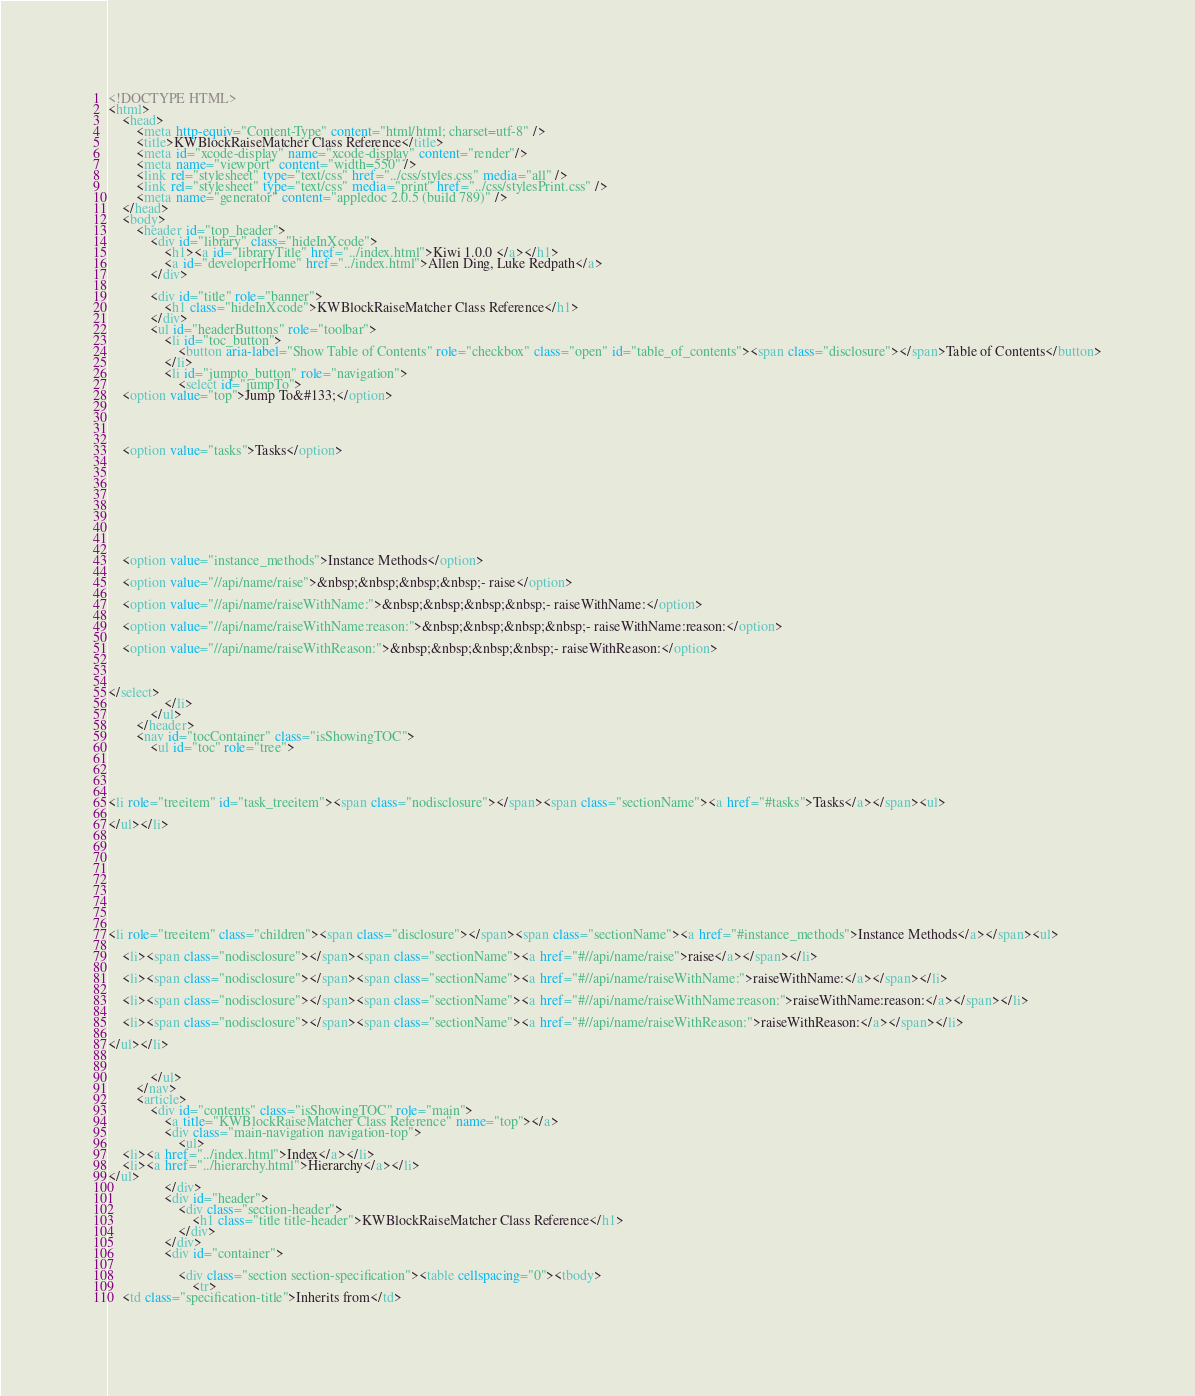<code> <loc_0><loc_0><loc_500><loc_500><_HTML_><!DOCTYPE HTML>
<html>
	<head>
		<meta http-equiv="Content-Type" content="html/html; charset=utf-8" />
		<title>KWBlockRaiseMatcher Class Reference</title>
		<meta id="xcode-display" name="xcode-display" content="render"/>
		<meta name="viewport" content="width=550" />
		<link rel="stylesheet" type="text/css" href="../css/styles.css" media="all" />
		<link rel="stylesheet" type="text/css" media="print" href="../css/stylesPrint.css" />
		<meta name="generator" content="appledoc 2.0.5 (build 789)" />
	</head>
	<body>
		<header id="top_header">
			<div id="library" class="hideInXcode">
				<h1><a id="libraryTitle" href="../index.html">Kiwi 1.0.0 </a></h1>
				<a id="developerHome" href="../index.html">Allen Ding, Luke Redpath</a>
			</div>
			
			<div id="title" role="banner">
				<h1 class="hideInXcode">KWBlockRaiseMatcher Class Reference</h1>
			</div>
			<ul id="headerButtons" role="toolbar">
				<li id="toc_button">
					<button aria-label="Show Table of Contents" role="checkbox" class="open" id="table_of_contents"><span class="disclosure"></span>Table of Contents</button>
				</li>
				<li id="jumpto_button" role="navigation">
					<select id="jumpTo">
	<option value="top">Jump To&#133;</option>
	
	
	
	
	<option value="tasks">Tasks</option>
	
	
	
	
	
	
	
	
	
	<option value="instance_methods">Instance Methods</option>
	
	<option value="//api/name/raise">&nbsp;&nbsp;&nbsp;&nbsp;- raise</option>
	
	<option value="//api/name/raiseWithName:">&nbsp;&nbsp;&nbsp;&nbsp;- raiseWithName:</option>
	
	<option value="//api/name/raiseWithName:reason:">&nbsp;&nbsp;&nbsp;&nbsp;- raiseWithName:reason:</option>
	
	<option value="//api/name/raiseWithReason:">&nbsp;&nbsp;&nbsp;&nbsp;- raiseWithReason:</option>
	
	
	
</select>
				</li>
			</ul>
		</header>
		<nav id="tocContainer" class="isShowingTOC">
			<ul id="toc" role="tree">
				



<li role="treeitem" id="task_treeitem"><span class="nodisclosure"></span><span class="sectionName"><a href="#tasks">Tasks</a></span><ul>
	
</ul></li>









<li role="treeitem" class="children"><span class="disclosure"></span><span class="sectionName"><a href="#instance_methods">Instance Methods</a></span><ul>
	
	<li><span class="nodisclosure"></span><span class="sectionName"><a href="#//api/name/raise">raise</a></span></li>
	
	<li><span class="nodisclosure"></span><span class="sectionName"><a href="#//api/name/raiseWithName:">raiseWithName:</a></span></li>
	
	<li><span class="nodisclosure"></span><span class="sectionName"><a href="#//api/name/raiseWithName:reason:">raiseWithName:reason:</a></span></li>
	
	<li><span class="nodisclosure"></span><span class="sectionName"><a href="#//api/name/raiseWithReason:">raiseWithReason:</a></span></li>
	
</ul></li>


			</ul>
		</nav>
		<article>
			<div id="contents" class="isShowingTOC" role="main">
				<a title="KWBlockRaiseMatcher Class Reference" name="top"></a>
				<div class="main-navigation navigation-top">
					<ul>
	<li><a href="../index.html">Index</a></li>
	<li><a href="../hierarchy.html">Hierarchy</a></li>
</ul>
				</div>
				<div id="header">
					<div class="section-header">
						<h1 class="title title-header">KWBlockRaiseMatcher Class Reference</h1>
					</div>		
				</div>
				<div id="container">	
					
					<div class="section section-specification"><table cellspacing="0"><tbody>
						<tr>
	<td class="specification-title">Inherits from</td></code> 